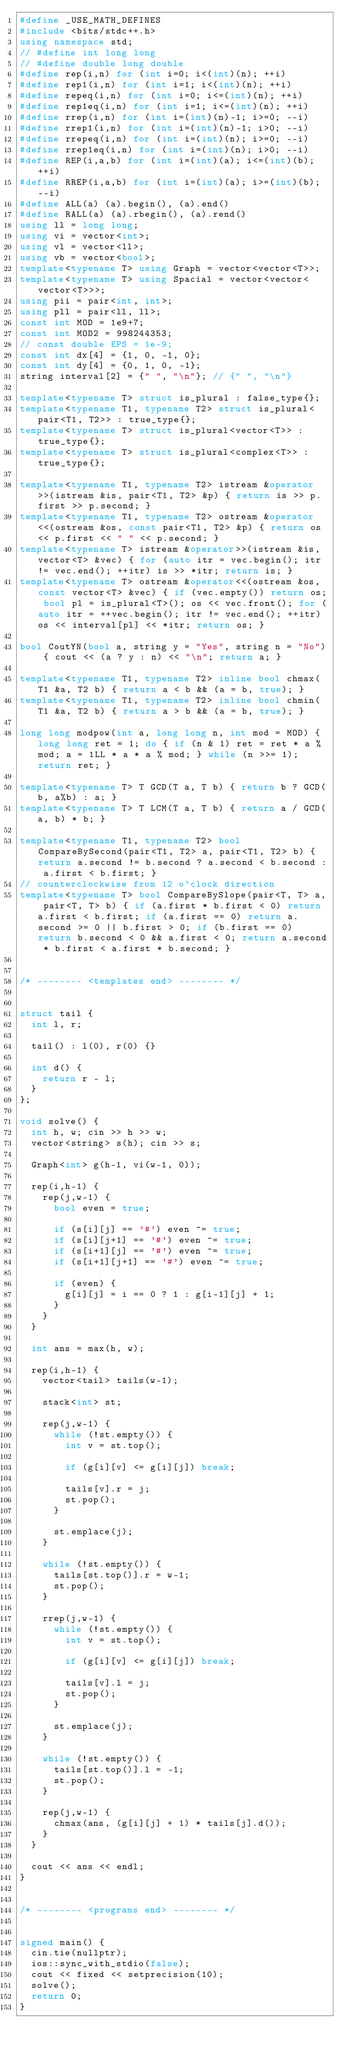<code> <loc_0><loc_0><loc_500><loc_500><_C++_>#define _USE_MATH_DEFINES
#include <bits/stdc++.h>
using namespace std;
// #define int long long
// #define double long double
#define rep(i,n) for (int i=0; i<(int)(n); ++i)
#define rep1(i,n) for (int i=1; i<(int)(n); ++i)
#define repeq(i,n) for (int i=0; i<=(int)(n); ++i)
#define rep1eq(i,n) for (int i=1; i<=(int)(n); ++i)
#define rrep(i,n) for (int i=(int)(n)-1; i>=0; --i)
#define rrep1(i,n) for (int i=(int)(n)-1; i>0; --i)
#define rrepeq(i,n) for (int i=(int)(n); i>=0; --i)
#define rrep1eq(i,n) for (int i=(int)(n); i>0; --i)
#define REP(i,a,b) for (int i=(int)(a); i<=(int)(b); ++i)
#define RREP(i,a,b) for (int i=(int)(a); i>=(int)(b); --i)
#define ALL(a) (a).begin(), (a).end()
#define RALL(a) (a).rbegin(), (a).rend()
using ll = long long;
using vi = vector<int>;
using vl = vector<ll>;
using vb = vector<bool>;
template<typename T> using Graph = vector<vector<T>>;
template<typename T> using Spacial = vector<vector<vector<T>>>;
using pii = pair<int, int>;
using pll = pair<ll, ll>;
const int MOD = 1e9+7;
const int MOD2 = 998244353;
// const double EPS = 1e-9;
const int dx[4] = {1, 0, -1, 0};
const int dy[4] = {0, 1, 0, -1};
string interval[2] = {" ", "\n"}; // {" ", "\n"}

template<typename T> struct is_plural : false_type{};
template<typename T1, typename T2> struct is_plural<pair<T1, T2>> : true_type{};
template<typename T> struct is_plural<vector<T>> : true_type{};
template<typename T> struct is_plural<complex<T>> : true_type{};
 
template<typename T1, typename T2> istream &operator>>(istream &is, pair<T1, T2> &p) { return is >> p.first >> p.second; }
template<typename T1, typename T2> ostream &operator<<(ostream &os, const pair<T1, T2> &p) { return os << p.first << " " << p.second; }
template<typename T> istream &operator>>(istream &is, vector<T> &vec) { for (auto itr = vec.begin(); itr != vec.end(); ++itr) is >> *itr; return is; }
template<typename T> ostream &operator<<(ostream &os, const vector<T> &vec) { if (vec.empty()) return os; bool pl = is_plural<T>(); os << vec.front(); for (auto itr = ++vec.begin(); itr != vec.end(); ++itr) os << interval[pl] << *itr; return os; }
 
bool CoutYN(bool a, string y = "Yes", string n = "No") { cout << (a ? y : n) << "\n"; return a; }

template<typename T1, typename T2> inline bool chmax(T1 &a, T2 b) { return a < b && (a = b, true); }
template<typename T1, typename T2> inline bool chmin(T1 &a, T2 b) { return a > b && (a = b, true); }

long long modpow(int a, long long n, int mod = MOD) { long long ret = 1; do { if (n & 1) ret = ret * a % mod; a = 1LL * a * a % mod; } while (n >>= 1); return ret; }

template<typename T> T GCD(T a, T b) { return b ? GCD(b, a%b) : a; }
template<typename T> T LCM(T a, T b) { return a / GCD(a, b) * b; }

template<typename T1, typename T2> bool CompareBySecond(pair<T1, T2> a, pair<T1, T2> b) { return a.second != b.second ? a.second < b.second : a.first < b.first; }
// counterclockwise from 12 o'clock direction
template<typename T> bool CompareBySlope(pair<T, T> a, pair<T, T> b) { if (a.first * b.first < 0) return a.first < b.first; if (a.first == 0) return a.second >= 0 || b.first > 0; if (b.first == 0) return b.second < 0 && a.first < 0; return a.second * b.first < a.first * b.second; }


/* -------- <templates end> -------- */


struct tail {
  int l, r;

  tail() : l(0), r(0) {}

  int d() {
    return r - l;
  }
};

void solve() {
  int h, w; cin >> h >> w;
  vector<string> s(h); cin >> s;
  
  Graph<int> g(h-1, vi(w-1, 0));

  rep(i,h-1) {
    rep(j,w-1) {
      bool even = true;

      if (s[i][j] == '#') even ^= true;
      if (s[i][j+1] == '#') even ^= true;
      if (s[i+1][j] == '#') even ^= true;
      if (s[i+1][j+1] == '#') even ^= true;

      if (even) {
        g[i][j] = i == 0 ? 1 : g[i-1][j] + 1;
      }
    }
  }

  int ans = max(h, w);

  rep(i,h-1) {
    vector<tail> tails(w-1);

    stack<int> st;

    rep(j,w-1) {
      while (!st.empty()) {
        int v = st.top();

        if (g[i][v] <= g[i][j]) break;

        tails[v].r = j;
        st.pop();
      }

      st.emplace(j);
    }

    while (!st.empty()) {
      tails[st.top()].r = w-1;
      st.pop();
    }

    rrep(j,w-1) {
      while (!st.empty()) {
        int v = st.top();

        if (g[i][v] <= g[i][j]) break;

        tails[v].l = j;
        st.pop();
      }

      st.emplace(j);
    }

    while (!st.empty()) {
      tails[st.top()].l = -1;
      st.pop();
    }

    rep(j,w-1) {
      chmax(ans, (g[i][j] + 1) * tails[j].d());
    }
  }

  cout << ans << endl;
}


/* -------- <programs end> -------- */


signed main() {
  cin.tie(nullptr);
  ios::sync_with_stdio(false);
  cout << fixed << setprecision(10);
  solve();
  return 0;
}
</code> 